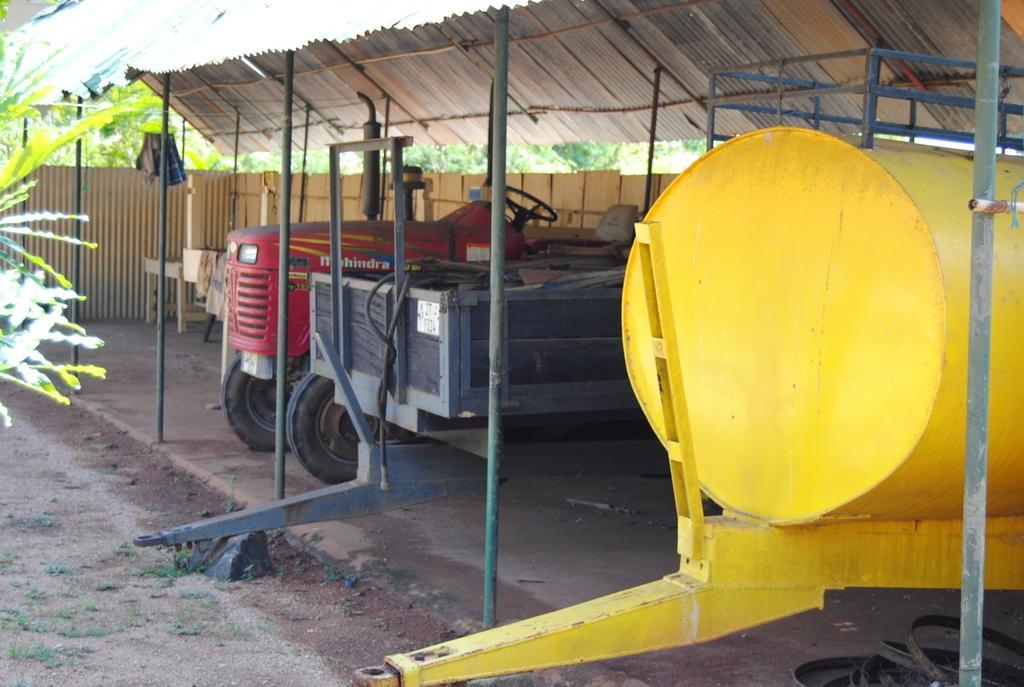Could you give a brief overview of what you see in this image? In this picture I can observe red color tractor in the middle of the picture. On the right side I can observe yellow color tanker. In the background there are trees. 